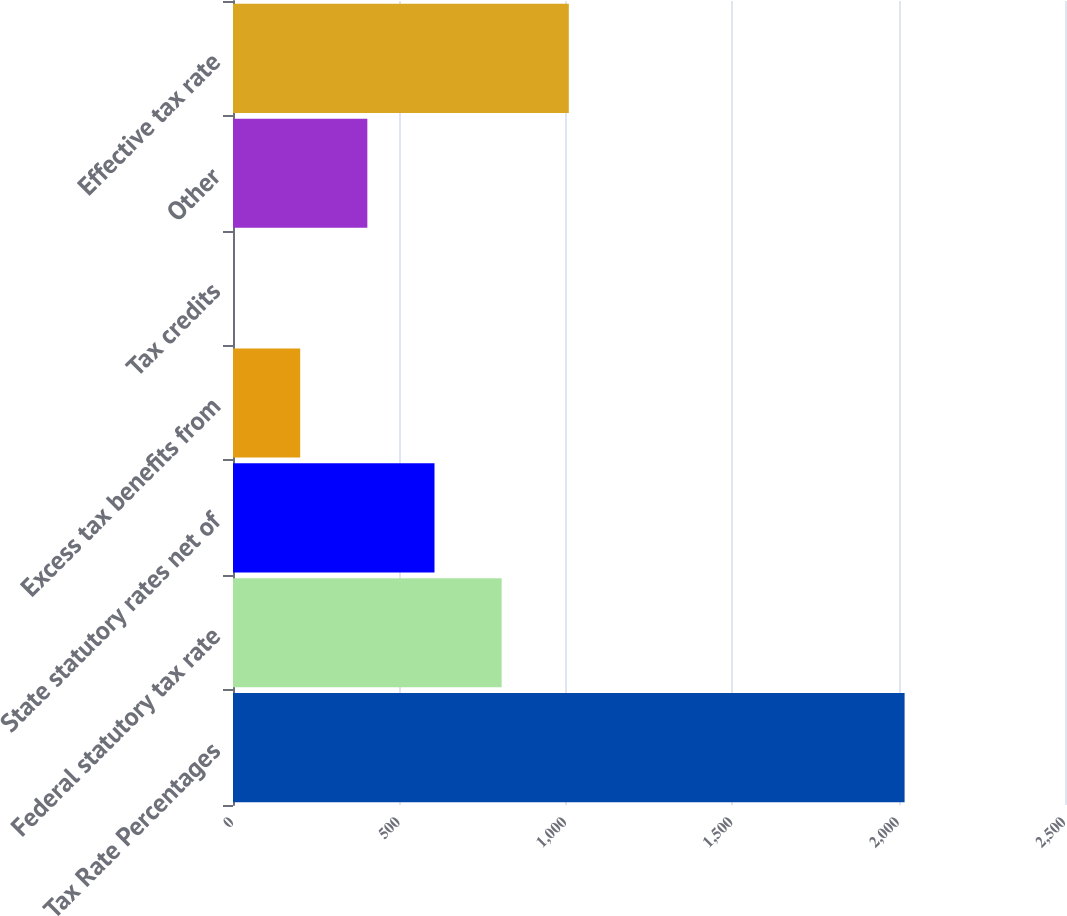<chart> <loc_0><loc_0><loc_500><loc_500><bar_chart><fcel>Tax Rate Percentages<fcel>Federal statutory tax rate<fcel>State statutory rates net of<fcel>Excess tax benefits from<fcel>Tax credits<fcel>Other<fcel>Effective tax rate<nl><fcel>2018<fcel>807.26<fcel>605.47<fcel>201.89<fcel>0.1<fcel>403.68<fcel>1009.05<nl></chart> 